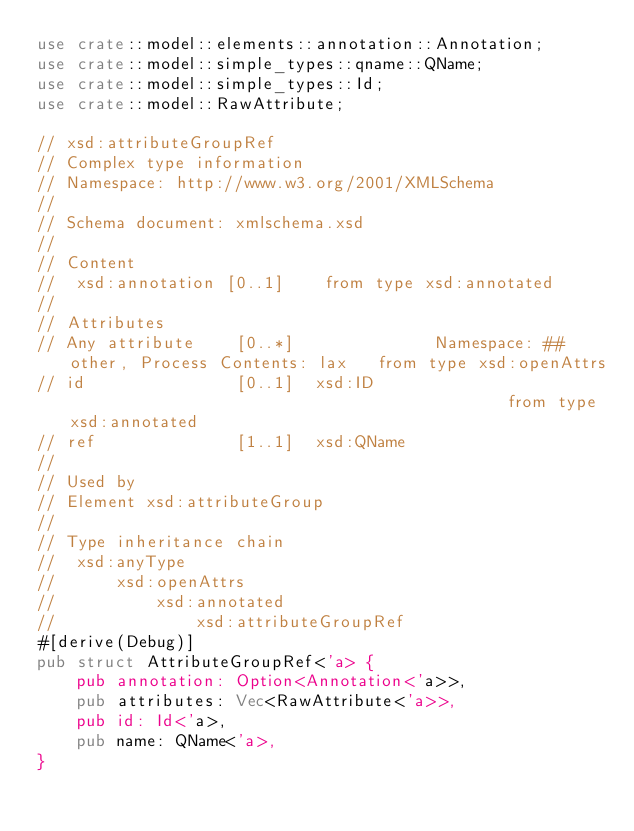<code> <loc_0><loc_0><loc_500><loc_500><_Rust_>use crate::model::elements::annotation::Annotation;
use crate::model::simple_types::qname::QName;
use crate::model::simple_types::Id;
use crate::model::RawAttribute;

// xsd:attributeGroupRef
// Complex type information
// Namespace: http://www.w3.org/2001/XMLSchema
//
// Schema document: xmlschema.xsd
//
// Content
//  xsd:annotation [0..1]    from type xsd:annotated
//
// Attributes
// Any attribute	[0..*]		        Namespace: ##other, Process Contents: lax	from type xsd:openAttrs
// id	            [0..1]	xsd:ID		                                            from type xsd:annotated
// ref	            [1..1]	xsd:QName
//
// Used by
// Element xsd:attributeGroup
//
// Type inheritance chain
//  xsd:anyType
//      xsd:openAttrs
//          xsd:annotated
//              xsd:attributeGroupRef
#[derive(Debug)]
pub struct AttributeGroupRef<'a> {
    pub annotation: Option<Annotation<'a>>,
    pub attributes: Vec<RawAttribute<'a>>,
    pub id: Id<'a>,
    pub name: QName<'a>,
}
</code> 